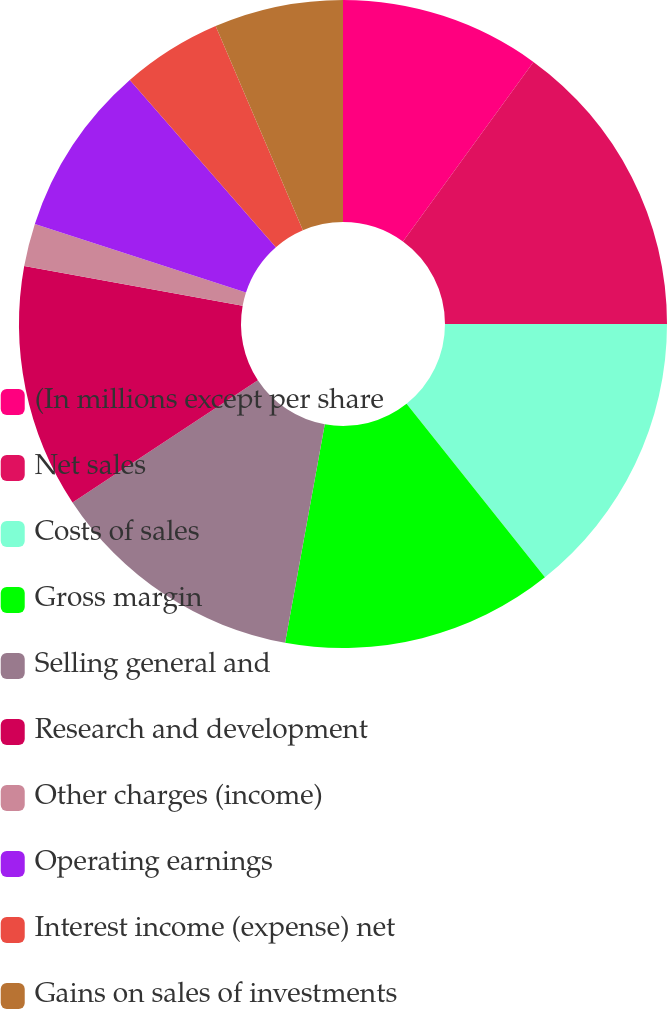Convert chart to OTSL. <chart><loc_0><loc_0><loc_500><loc_500><pie_chart><fcel>(In millions except per share<fcel>Net sales<fcel>Costs of sales<fcel>Gross margin<fcel>Selling general and<fcel>Research and development<fcel>Other charges (income)<fcel>Operating earnings<fcel>Interest income (expense) net<fcel>Gains on sales of investments<nl><fcel>10.0%<fcel>15.0%<fcel>14.29%<fcel>13.57%<fcel>12.86%<fcel>12.14%<fcel>2.14%<fcel>8.57%<fcel>5.0%<fcel>6.43%<nl></chart> 